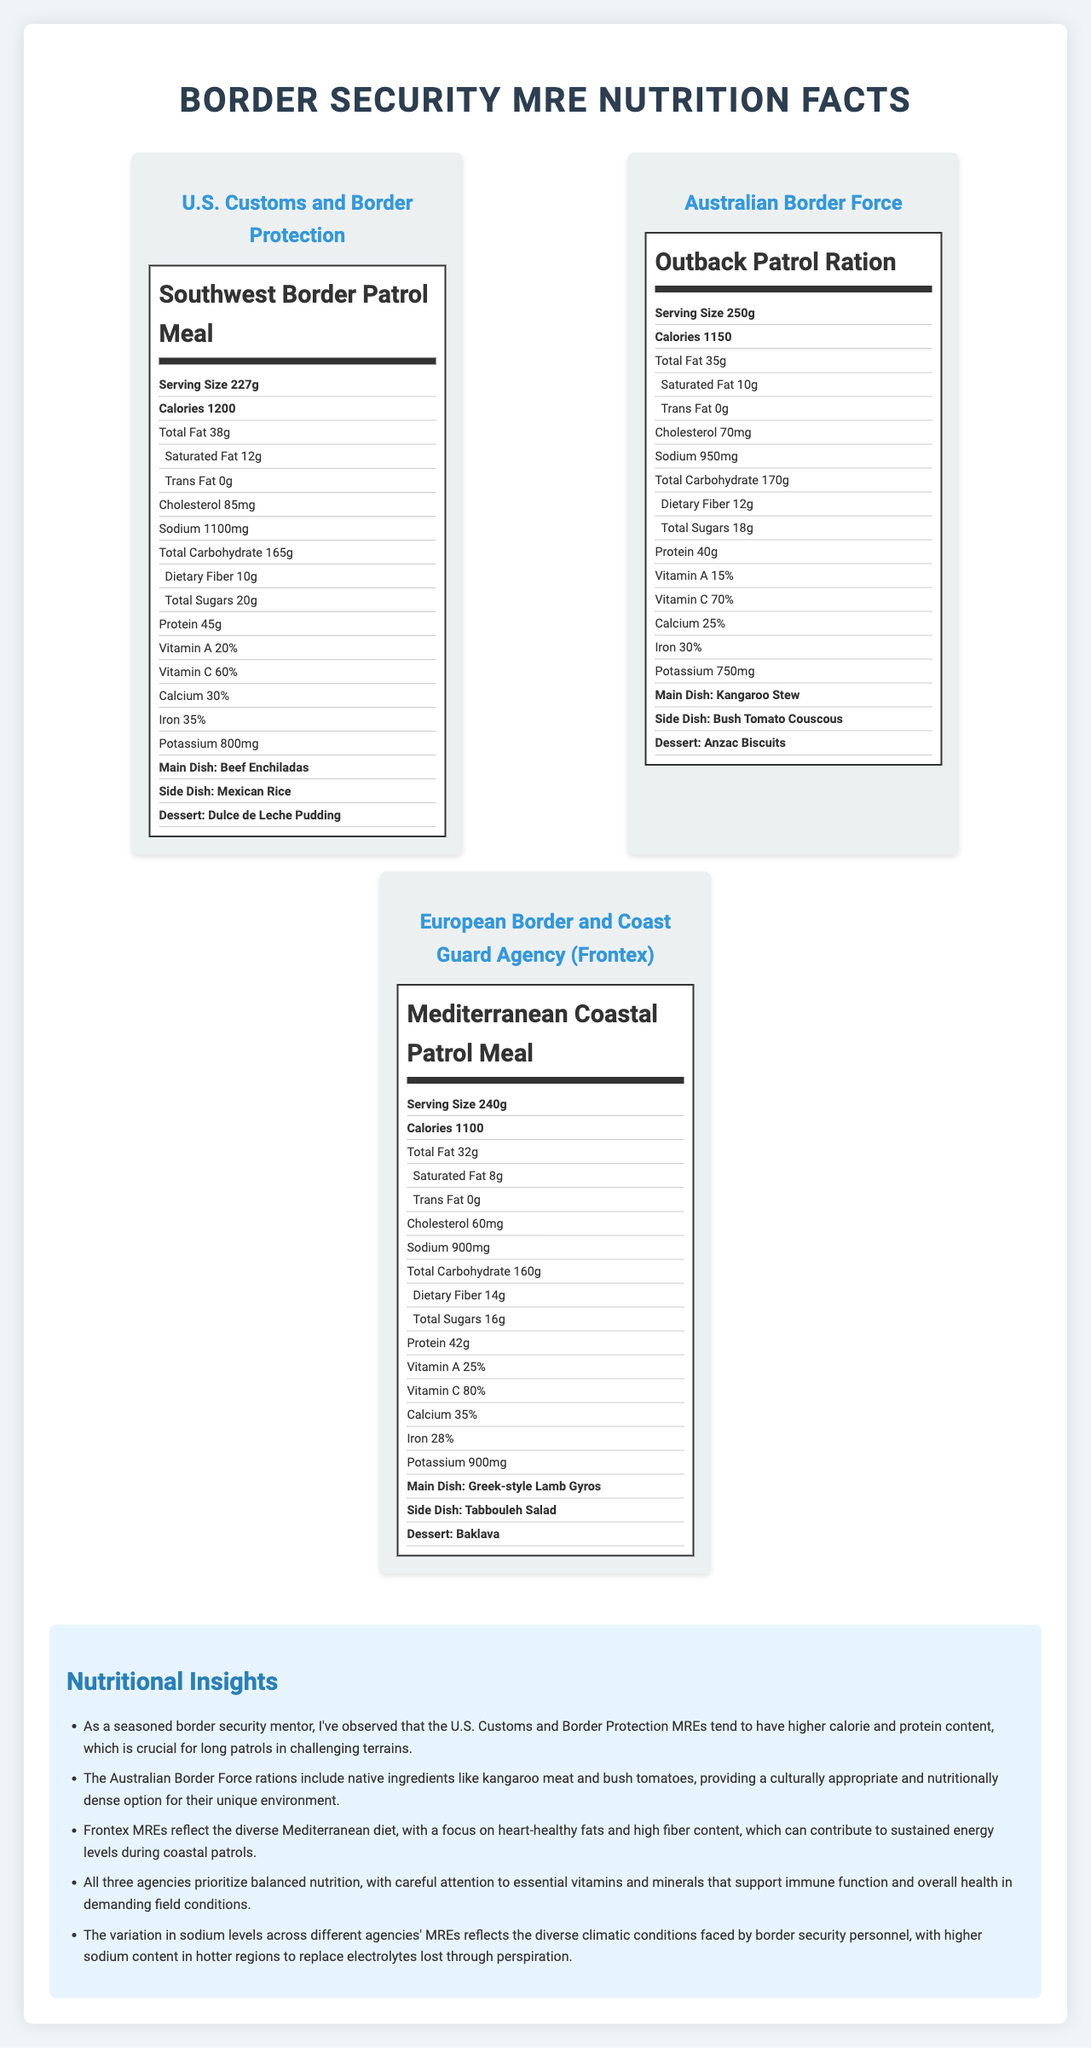what is the serving size of the Southwest Border Patrol Meal? The serving size for the Southwest Border Patrol Meal, provided by U.S. Customs and Border Protection, is stated as 227g in the document.
Answer: 227g which agency's MRE has the highest protein content? The U.S. Customs and Border Protection's Southwest Border Patrol Meal has the highest protein content, listed as 45g.
Answer: U.S. Customs and Border Protection what is the cholesterol content in the Mediterranean Coastal Patrol Meal? The document indicates that the Mediterranean Coastal Patrol Meal by Frontex contains 60mg of cholesterol.
Answer: 60mg how much dietary fiber is in the Outback Patrol Ration? The Australian Border Force’s Outback Patrol Ration contains 12g of dietary fiber, as shown in the document.
Answer: 12g which MRE has the lowest calorie content? The Mediterranean Coastal Patrol Meal by Frontex has the lowest calorie content at 1100 calories, according to the document.
Answer: Mediterranean Coastal Patrol Meal which MRE includes Beef Enchiladas as a main dish? A. Southwest Border Patrol Meal B. Outback Patrol Ration C. Mediterranean Coastal Patrol Meal The Southwest Border Patrol Meal from U.S. Customs and Border Protection includes Beef Enchiladas as the main dish.
Answer: A which of the following MREs has the highest Vitamin C percentage? 1. Southwest Border Patrol Meal 2. Outback Patrol Ration 3. Mediterranean Coastal Patrol Meal The Mediterranean Coastal Patrol Meal has the highest Vitamin C percentage at 80%.
Answer: 3 is the Total Sugars content of the Outback Patrol Ration higher than that of the Southwest Border Patrol Meal? The Southwest Border Patrol Meal contains 20g of sugars, while the Outback Patrol Ration has 18g, making it lower in total sugars.
Answer: No does every MRE listed in the document contain trans fat? The document specifies 0g of trans fat for all listed MREs, indicating that none of them contain trans fat.
Answer: No what is the main focus of the document? The document provides a comparative analysis of the nutrient compositions of MREs used by U.S. Customs and Border Protection, Australian Border Force, and Frontex, combined with expert nutritional insights.
Answer: Comparative nutrient breakdown of MREs used by different border security agencies, along with nutritional insights. how is the sodium content varied among the MREs depending on the climatic conditions? Although the document mentions the variation of sodium content due to different climatic conditions, it does not provide specific sodium levels tailored to these conditions.
Answer: Not enough information 